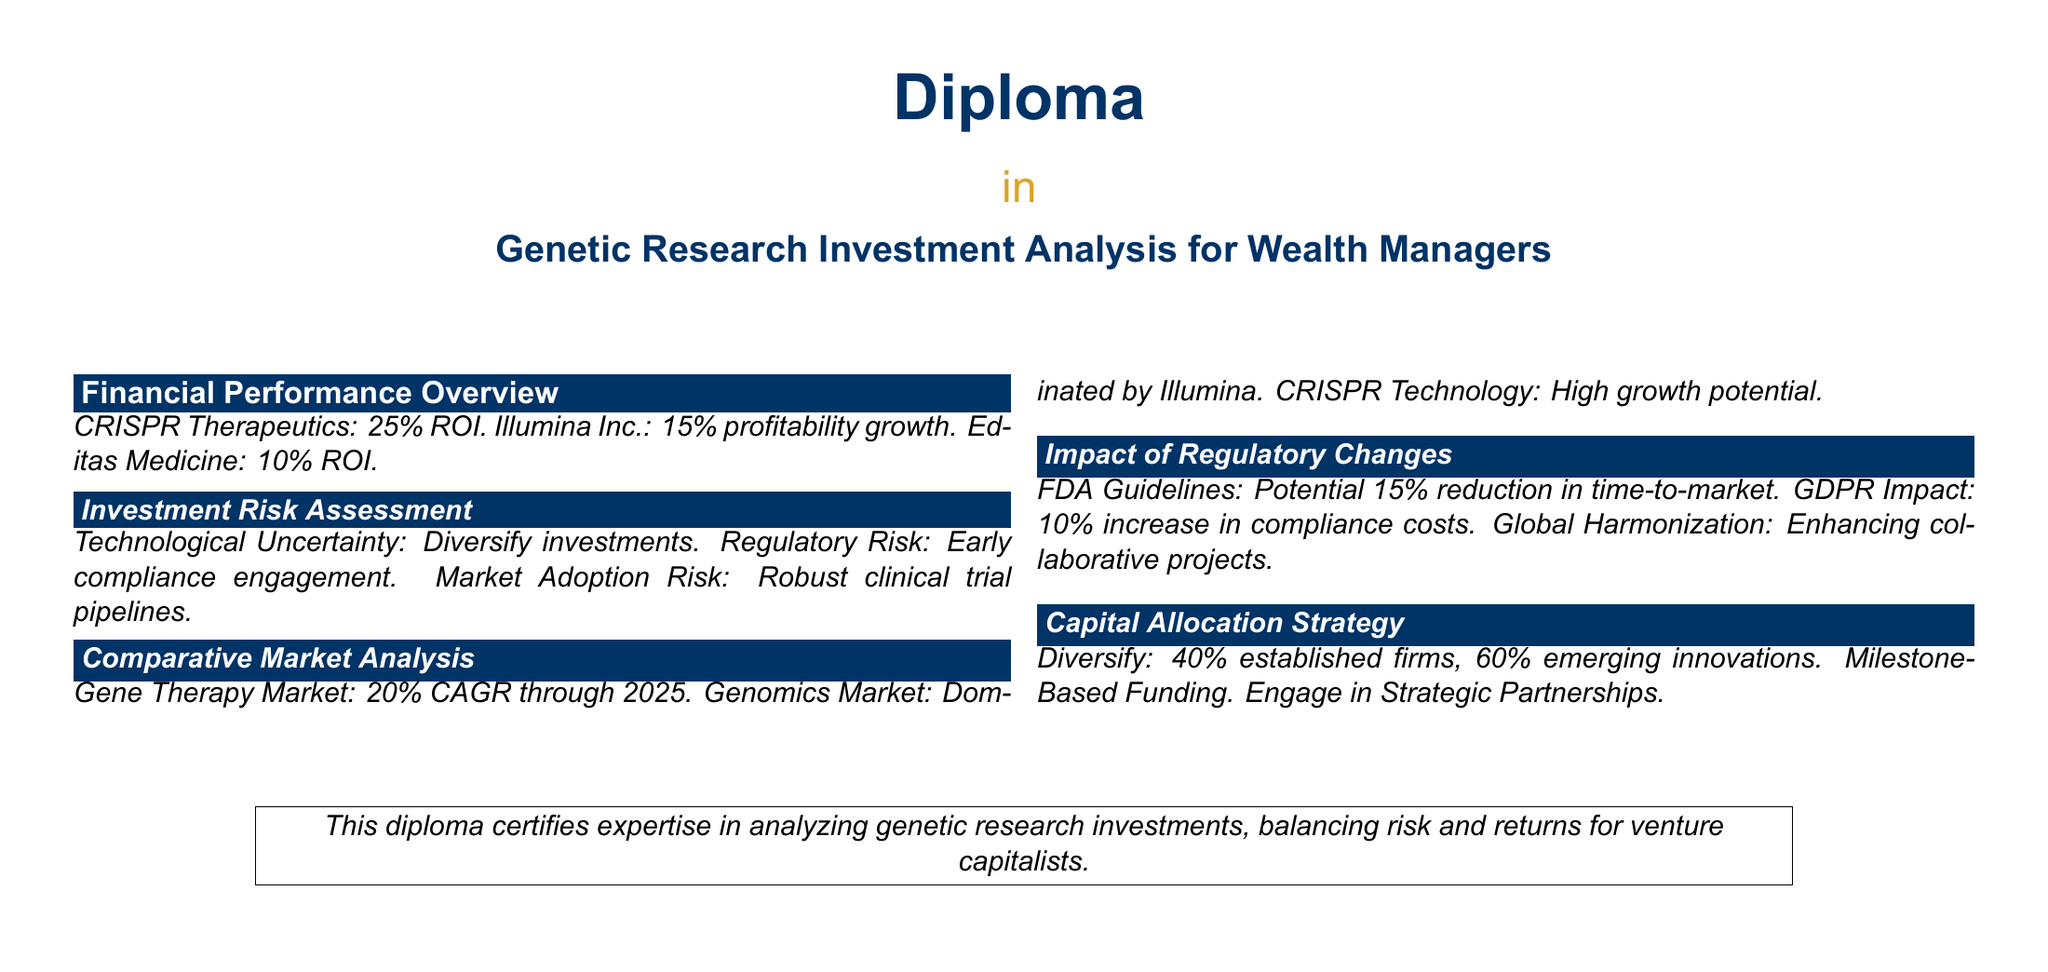What is the ROI for CRISPR Therapeutics? The ROI for CRISPR Therapeutics is stated specifically in the document.
Answer: 25% What percentage of established firms is recommended for capital allocation? The document clearly outlines a strategy for capital allocation percentages.
Answer: 40% What is the CAGR for the Gene Therapy Market through 2025? The CAGR is provided in the comparative market analysis section of the document.
Answer: 20% What is one of the risks associated with regulatory changes? The document mentions risks associated with regulatory changes and their impact on investments.
Answer: Compliance costs What is the profitability growth percentage for Illumina Inc.? The profitability growth of Illumina Inc. is explicitly mentioned in the financial performance overview.
Answer: 15% What should investors do to mitigate market adoption risk? The document suggests a specific action to address market adoption risk in the investment risk assessment section.
Answer: Robust clinical trial pipelines What major impact does FDA Guidelines have on time-to-market? The document discusses the effect of FDA Guidelines on the time-to-market for genetic research.
Answer: 15% reduction What portion of capital allocation is suggested for emerging innovations? The capital allocation strategy includes specific recommendations for emerging innovations.
Answer: 60% What is the potential market trend for CRISPR Technology? The document speaks to the growth potential of CRISPR Technology within the market analysis.
Answer: High growth potential 